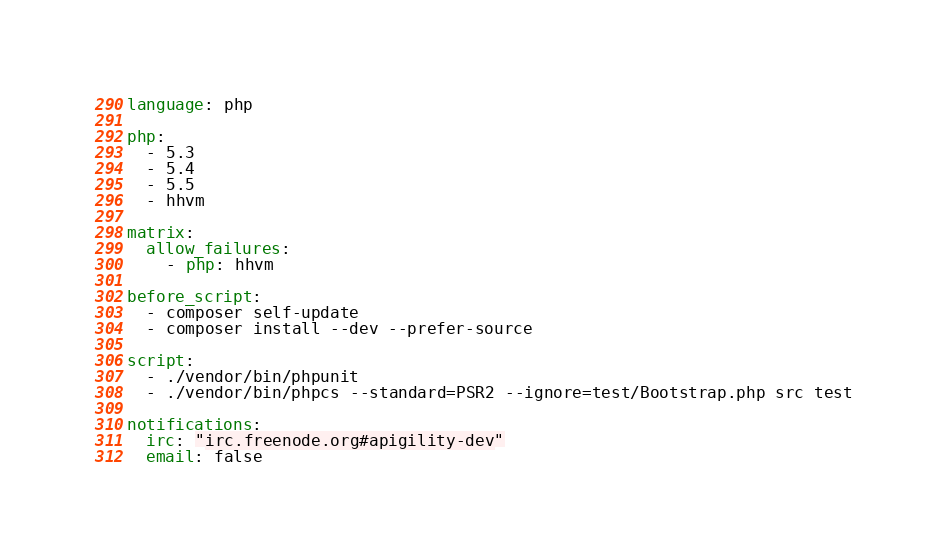Convert code to text. <code><loc_0><loc_0><loc_500><loc_500><_YAML_>language: php

php:
  - 5.3
  - 5.4
  - 5.5
  - hhvm

matrix:
  allow_failures:
    - php: hhvm

before_script:
  - composer self-update
  - composer install --dev --prefer-source

script:
  - ./vendor/bin/phpunit
  - ./vendor/bin/phpcs --standard=PSR2 --ignore=test/Bootstrap.php src test
  
notifications:
  irc: "irc.freenode.org#apigility-dev"
  email: false
</code> 